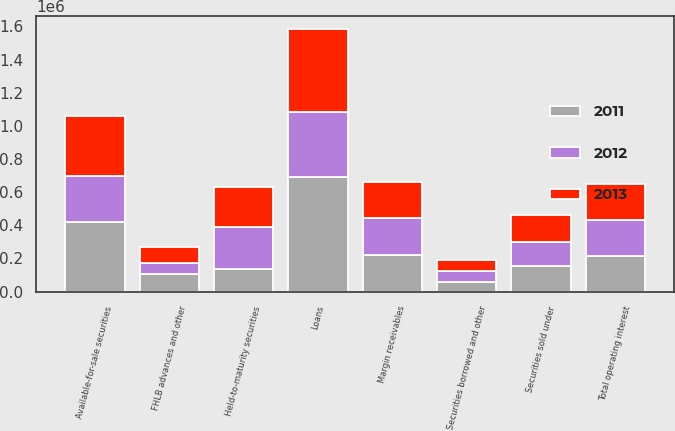Convert chart. <chart><loc_0><loc_0><loc_500><loc_500><stacked_bar_chart><ecel><fcel>Loans<fcel>Available-for-sale securities<fcel>Held-to-maturity securities<fcel>Margin receivables<fcel>Securities borrowed and other<fcel>Total operating interest<fcel>Securities sold under<fcel>FHLB advances and other<nl><fcel>2012<fcel>394633<fcel>278845<fcel>255458<fcel>223971<fcel>67005<fcel>216086<fcel>148399<fcel>68363<nl><fcel>2013<fcel>496466<fcel>359977<fcel>236961<fcel>216086<fcel>61608<fcel>216086<fcel>158518<fcel>92630<nl><fcel>2011<fcel>692127<fcel>421304<fcel>136953<fcel>221717<fcel>60238<fcel>216086<fcel>153079<fcel>106201<nl></chart> 